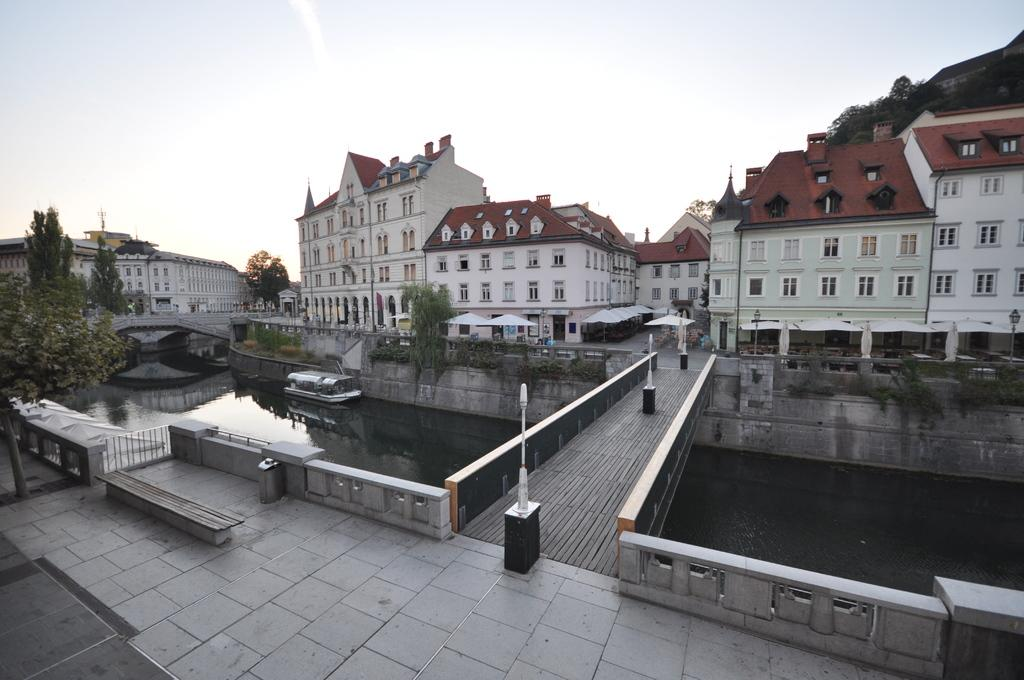What type of pathway is visible in the image? There is a road in the image. Where does the road lead to? The road connects to a bridge. What is the bridge built over? The bridge is over a lake. What can be seen on the lake? There is a ship on the lake. What structures are near the lake? There are buildings near the lake. What type of vegetation is near the lake? There are trees near the lake. How many degrees does the ship have on the lake? The image does not provide information about the ship's degrees; it only shows the ship on the lake. What type of legs can be seen supporting the trees near the lake? There are no legs visible in the image; the trees are standing on the ground near the lake. 